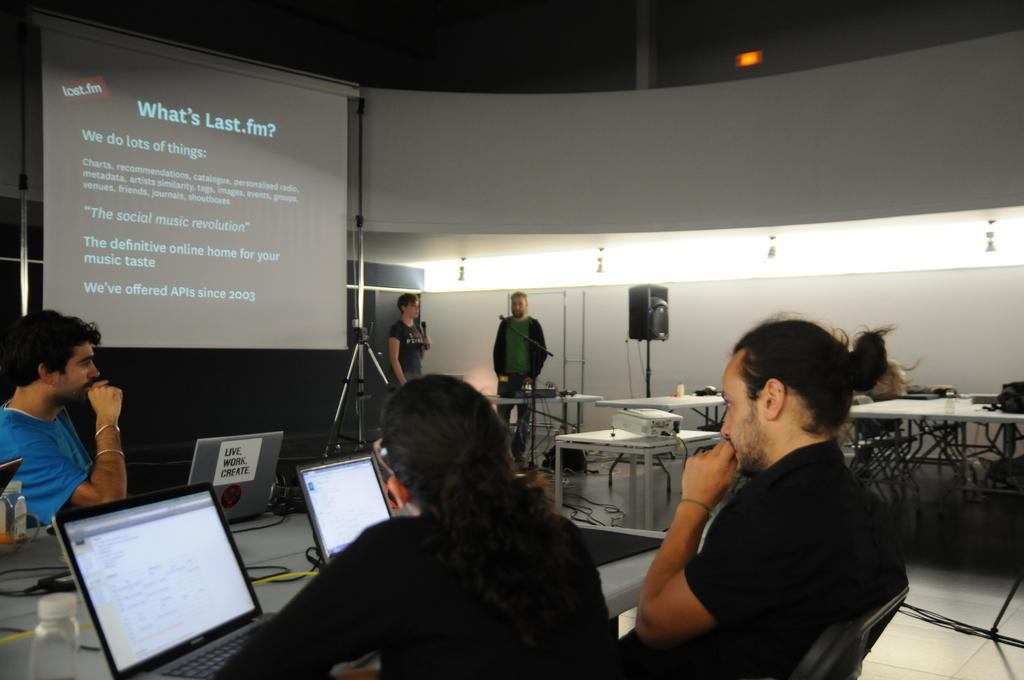<image>
Describe the image concisely. Projector in meeting room displaying information on Last.fm. 